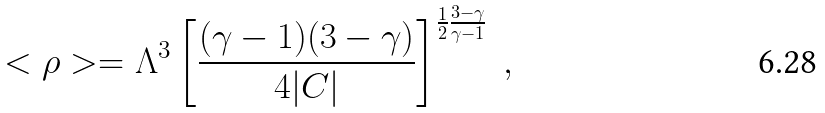<formula> <loc_0><loc_0><loc_500><loc_500>< \rho > = \Lambda ^ { 3 } \left [ \frac { ( \gamma - 1 ) ( 3 - \gamma ) } { 4 | C | } \right ] ^ { \frac { 1 } { 2 } \frac { 3 - \gamma } { \gamma - 1 } } \ ,</formula> 